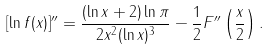<formula> <loc_0><loc_0><loc_500><loc_500>[ \ln f ( x ) ] ^ { \prime \prime } = \frac { ( \ln x + 2 ) \ln \pi } { 2 x ^ { 2 } ( \ln x ) ^ { 3 } } - \frac { 1 } { 2 } F ^ { \prime \prime } \left ( \frac { x } 2 \right ) .</formula> 